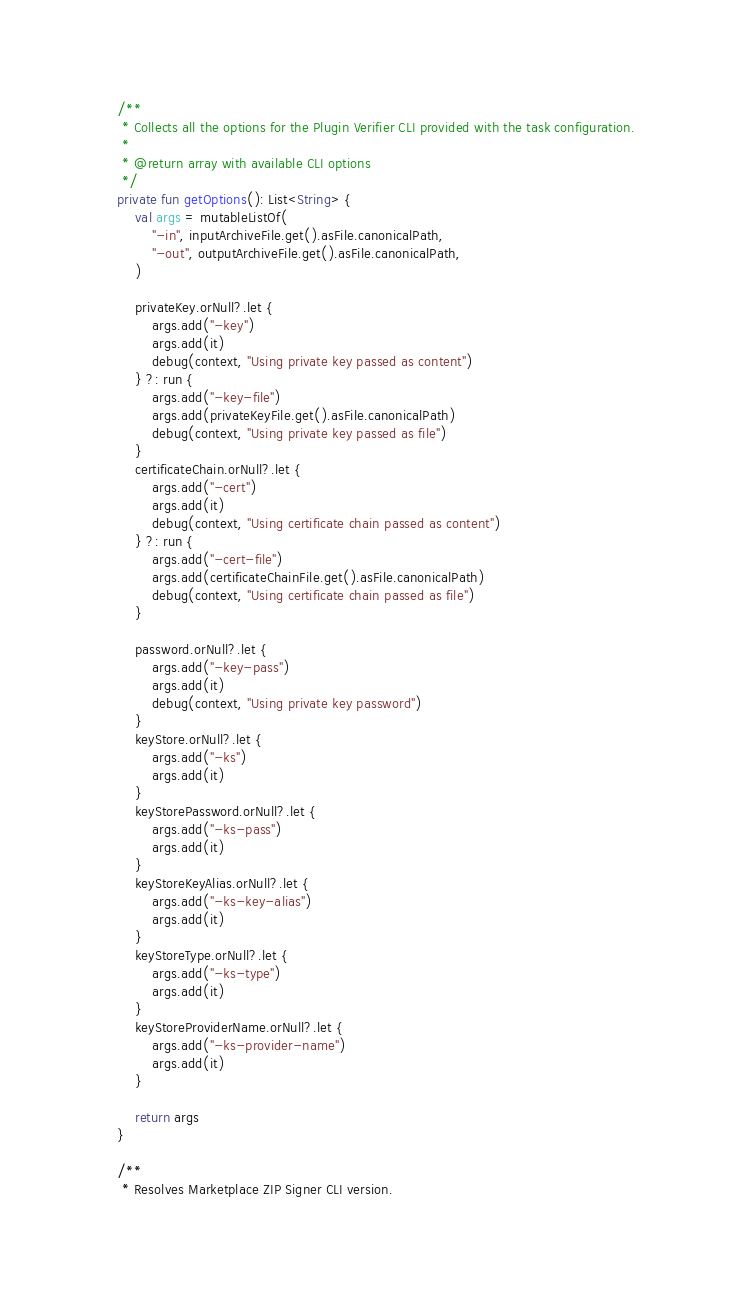<code> <loc_0><loc_0><loc_500><loc_500><_Kotlin_>    /**
     * Collects all the options for the Plugin Verifier CLI provided with the task configuration.
     *
     * @return array with available CLI options
     */
    private fun getOptions(): List<String> {
        val args = mutableListOf(
            "-in", inputArchiveFile.get().asFile.canonicalPath,
            "-out", outputArchiveFile.get().asFile.canonicalPath,
        )

        privateKey.orNull?.let {
            args.add("-key")
            args.add(it)
            debug(context, "Using private key passed as content")
        } ?: run {
            args.add("-key-file")
            args.add(privateKeyFile.get().asFile.canonicalPath)
            debug(context, "Using private key passed as file")
        }
        certificateChain.orNull?.let {
            args.add("-cert")
            args.add(it)
            debug(context, "Using certificate chain passed as content")
        } ?: run {
            args.add("-cert-file")
            args.add(certificateChainFile.get().asFile.canonicalPath)
            debug(context, "Using certificate chain passed as file")
        }

        password.orNull?.let {
            args.add("-key-pass")
            args.add(it)
            debug(context, "Using private key password")
        }
        keyStore.orNull?.let {
            args.add("-ks")
            args.add(it)
        }
        keyStorePassword.orNull?.let {
            args.add("-ks-pass")
            args.add(it)
        }
        keyStoreKeyAlias.orNull?.let {
            args.add("-ks-key-alias")
            args.add(it)
        }
        keyStoreType.orNull?.let {
            args.add("-ks-type")
            args.add(it)
        }
        keyStoreProviderName.orNull?.let {
            args.add("-ks-provider-name")
            args.add(it)
        }

        return args
    }

    /**
     * Resolves Marketplace ZIP Signer CLI version.</code> 